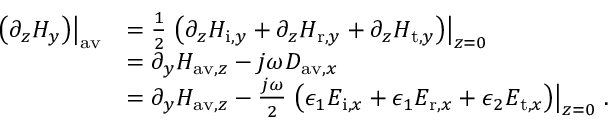<formula> <loc_0><loc_0><loc_500><loc_500>\begin{array} { r l } { \left ( \partial _ { z } H _ { y } \right ) \right | _ { a v } } & { = \frac { 1 } { 2 } \left ( \partial _ { z } H _ { i , y } + \partial _ { z } H _ { r , y } + \partial _ { z } H _ { t , y } \right ) \right | _ { z = 0 } } \\ & { = \partial _ { y } H _ { a v , z } - j \omega D _ { a v , x } } \\ & { = \partial _ { y } H _ { a v , z } - \frac { j \omega } { 2 } \left ( \epsilon _ { 1 } E _ { i , x } + \epsilon _ { 1 } E _ { r , x } + \epsilon _ { 2 } E _ { t , x } \right ) \right | _ { z = 0 } \, . } \end{array}</formula> 